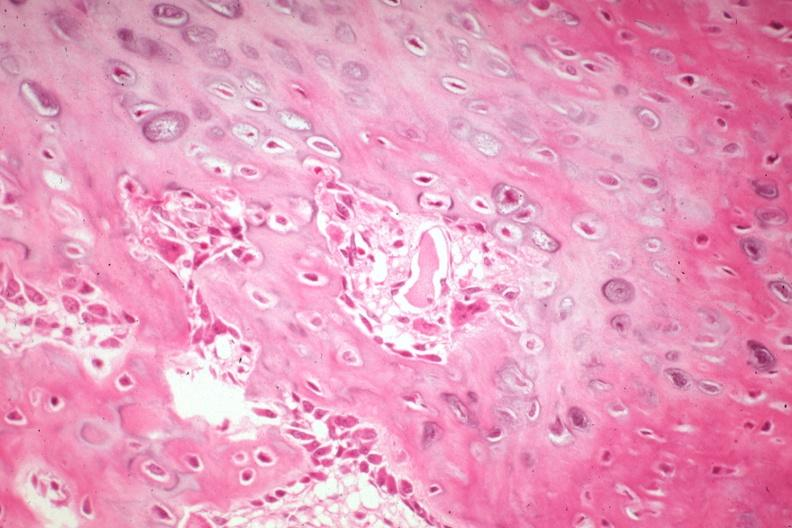what does this image show?
Answer the question using a single word or phrase. High excellent enchondral bone formation with osteoid osteoblasts osteoclasts 